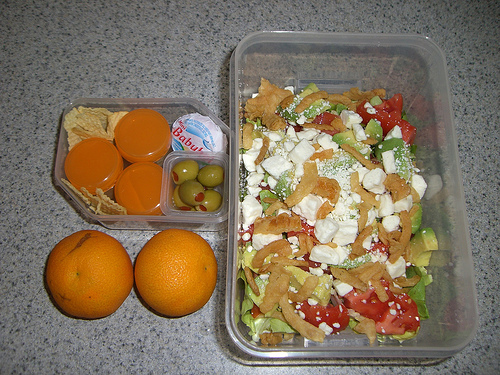<image>
Is the food on the table? Yes. Looking at the image, I can see the food is positioned on top of the table, with the table providing support. Is the food to the left of the orange? No. The food is not to the left of the orange. From this viewpoint, they have a different horizontal relationship. 